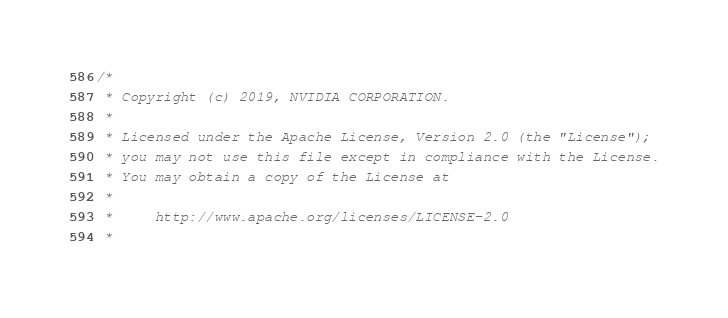Convert code to text. <code><loc_0><loc_0><loc_500><loc_500><_Cuda_>/*
 * Copyright (c) 2019, NVIDIA CORPORATION.
 *
 * Licensed under the Apache License, Version 2.0 (the "License");
 * you may not use this file except in compliance with the License.
 * You may obtain a copy of the License at
 *
 *     http://www.apache.org/licenses/LICENSE-2.0
 *</code> 